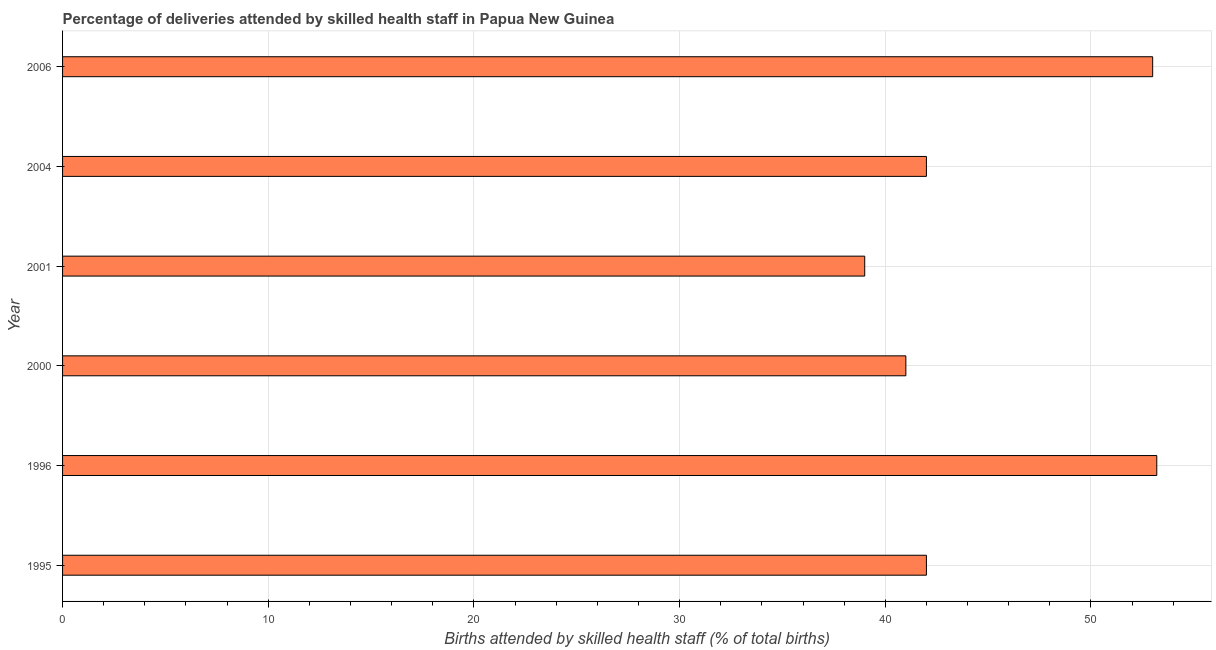What is the title of the graph?
Provide a short and direct response. Percentage of deliveries attended by skilled health staff in Papua New Guinea. What is the label or title of the X-axis?
Provide a succinct answer. Births attended by skilled health staff (% of total births). What is the label or title of the Y-axis?
Offer a very short reply. Year. Across all years, what is the maximum number of births attended by skilled health staff?
Your answer should be very brief. 53.2. In which year was the number of births attended by skilled health staff maximum?
Offer a terse response. 1996. What is the sum of the number of births attended by skilled health staff?
Provide a short and direct response. 270.2. What is the difference between the number of births attended by skilled health staff in 2000 and 2004?
Offer a terse response. -1. What is the average number of births attended by skilled health staff per year?
Your response must be concise. 45.03. What is the median number of births attended by skilled health staff?
Offer a terse response. 42. In how many years, is the number of births attended by skilled health staff greater than 20 %?
Provide a short and direct response. 6. Do a majority of the years between 2000 and 1995 (inclusive) have number of births attended by skilled health staff greater than 44 %?
Provide a short and direct response. Yes. What is the ratio of the number of births attended by skilled health staff in 2000 to that in 2004?
Ensure brevity in your answer.  0.98. Is the number of births attended by skilled health staff in 1995 less than that in 2000?
Your response must be concise. No. Is the difference between the number of births attended by skilled health staff in 2001 and 2004 greater than the difference between any two years?
Keep it short and to the point. No. What is the difference between the highest and the second highest number of births attended by skilled health staff?
Provide a short and direct response. 0.2. What is the difference between the highest and the lowest number of births attended by skilled health staff?
Make the answer very short. 14.2. Are all the bars in the graph horizontal?
Your answer should be compact. Yes. What is the Births attended by skilled health staff (% of total births) of 1995?
Give a very brief answer. 42. What is the Births attended by skilled health staff (% of total births) of 1996?
Offer a terse response. 53.2. What is the difference between the Births attended by skilled health staff (% of total births) in 1995 and 2000?
Make the answer very short. 1. What is the difference between the Births attended by skilled health staff (% of total births) in 1995 and 2004?
Ensure brevity in your answer.  0. What is the difference between the Births attended by skilled health staff (% of total births) in 1996 and 2000?
Ensure brevity in your answer.  12.2. What is the difference between the Births attended by skilled health staff (% of total births) in 1996 and 2001?
Offer a terse response. 14.2. What is the difference between the Births attended by skilled health staff (% of total births) in 2000 and 2004?
Offer a very short reply. -1. What is the difference between the Births attended by skilled health staff (% of total births) in 2000 and 2006?
Offer a terse response. -12. What is the difference between the Births attended by skilled health staff (% of total births) in 2001 and 2006?
Provide a succinct answer. -14. What is the difference between the Births attended by skilled health staff (% of total births) in 2004 and 2006?
Keep it short and to the point. -11. What is the ratio of the Births attended by skilled health staff (% of total births) in 1995 to that in 1996?
Give a very brief answer. 0.79. What is the ratio of the Births attended by skilled health staff (% of total births) in 1995 to that in 2000?
Give a very brief answer. 1.02. What is the ratio of the Births attended by skilled health staff (% of total births) in 1995 to that in 2001?
Ensure brevity in your answer.  1.08. What is the ratio of the Births attended by skilled health staff (% of total births) in 1995 to that in 2004?
Your answer should be very brief. 1. What is the ratio of the Births attended by skilled health staff (% of total births) in 1995 to that in 2006?
Keep it short and to the point. 0.79. What is the ratio of the Births attended by skilled health staff (% of total births) in 1996 to that in 2000?
Provide a succinct answer. 1.3. What is the ratio of the Births attended by skilled health staff (% of total births) in 1996 to that in 2001?
Offer a terse response. 1.36. What is the ratio of the Births attended by skilled health staff (% of total births) in 1996 to that in 2004?
Offer a very short reply. 1.27. What is the ratio of the Births attended by skilled health staff (% of total births) in 1996 to that in 2006?
Give a very brief answer. 1. What is the ratio of the Births attended by skilled health staff (% of total births) in 2000 to that in 2001?
Keep it short and to the point. 1.05. What is the ratio of the Births attended by skilled health staff (% of total births) in 2000 to that in 2006?
Your response must be concise. 0.77. What is the ratio of the Births attended by skilled health staff (% of total births) in 2001 to that in 2004?
Ensure brevity in your answer.  0.93. What is the ratio of the Births attended by skilled health staff (% of total births) in 2001 to that in 2006?
Ensure brevity in your answer.  0.74. What is the ratio of the Births attended by skilled health staff (% of total births) in 2004 to that in 2006?
Your answer should be compact. 0.79. 